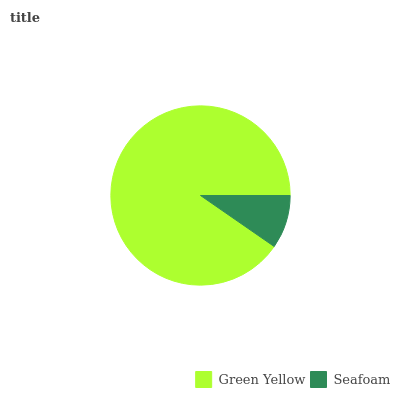Is Seafoam the minimum?
Answer yes or no. Yes. Is Green Yellow the maximum?
Answer yes or no. Yes. Is Seafoam the maximum?
Answer yes or no. No. Is Green Yellow greater than Seafoam?
Answer yes or no. Yes. Is Seafoam less than Green Yellow?
Answer yes or no. Yes. Is Seafoam greater than Green Yellow?
Answer yes or no. No. Is Green Yellow less than Seafoam?
Answer yes or no. No. Is Green Yellow the high median?
Answer yes or no. Yes. Is Seafoam the low median?
Answer yes or no. Yes. Is Seafoam the high median?
Answer yes or no. No. Is Green Yellow the low median?
Answer yes or no. No. 